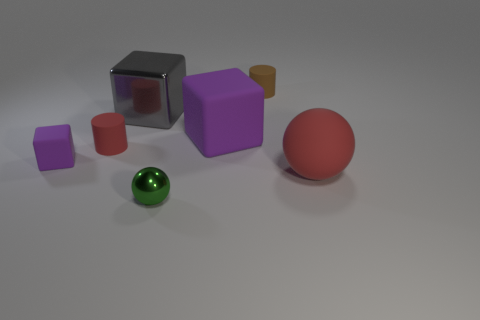How many things are tiny matte cylinders on the right side of the green metal thing or small rubber objects that are to the right of the small green metal object?
Give a very brief answer. 1. What color is the small metal sphere in front of the small cylinder that is to the left of the green metal thing?
Provide a short and direct response. Green. There is a tiny cube that is made of the same material as the large ball; what is its color?
Your response must be concise. Purple. How many large rubber things are the same color as the tiny metal object?
Make the answer very short. 0. What number of objects are either large cyan rubber cylinders or red rubber balls?
Your answer should be compact. 1. What shape is the purple matte object that is the same size as the rubber sphere?
Make the answer very short. Cube. How many matte things are both on the left side of the rubber ball and in front of the brown cylinder?
Keep it short and to the point. 3. There is a ball left of the large ball; what is its material?
Ensure brevity in your answer.  Metal. The ball that is the same material as the tiny red object is what size?
Make the answer very short. Large. There is a purple block to the right of the large gray metallic cube; is it the same size as the red rubber thing that is right of the large metallic block?
Offer a terse response. Yes. 